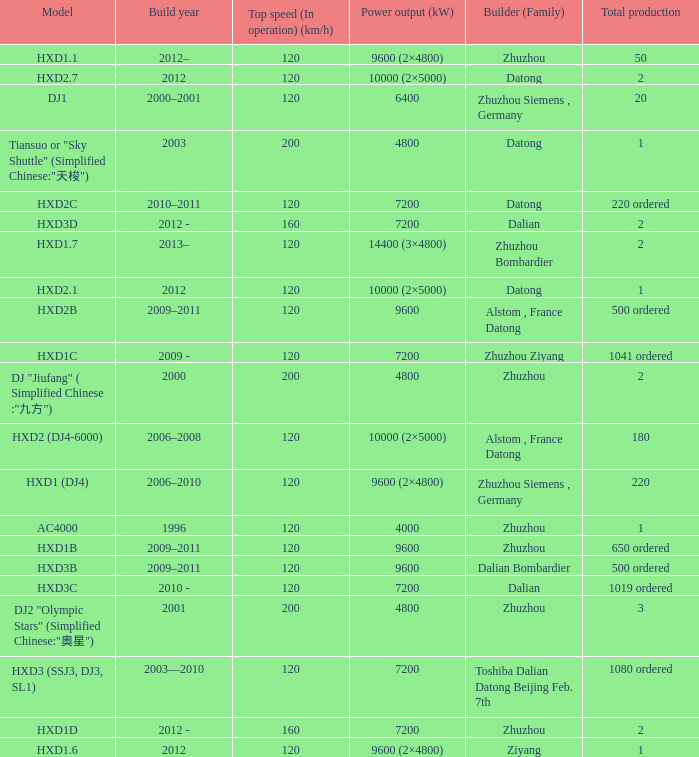What is the power output (kw) of builder zhuzhou, model hxd1d, with a total production of 2? 7200.0. 